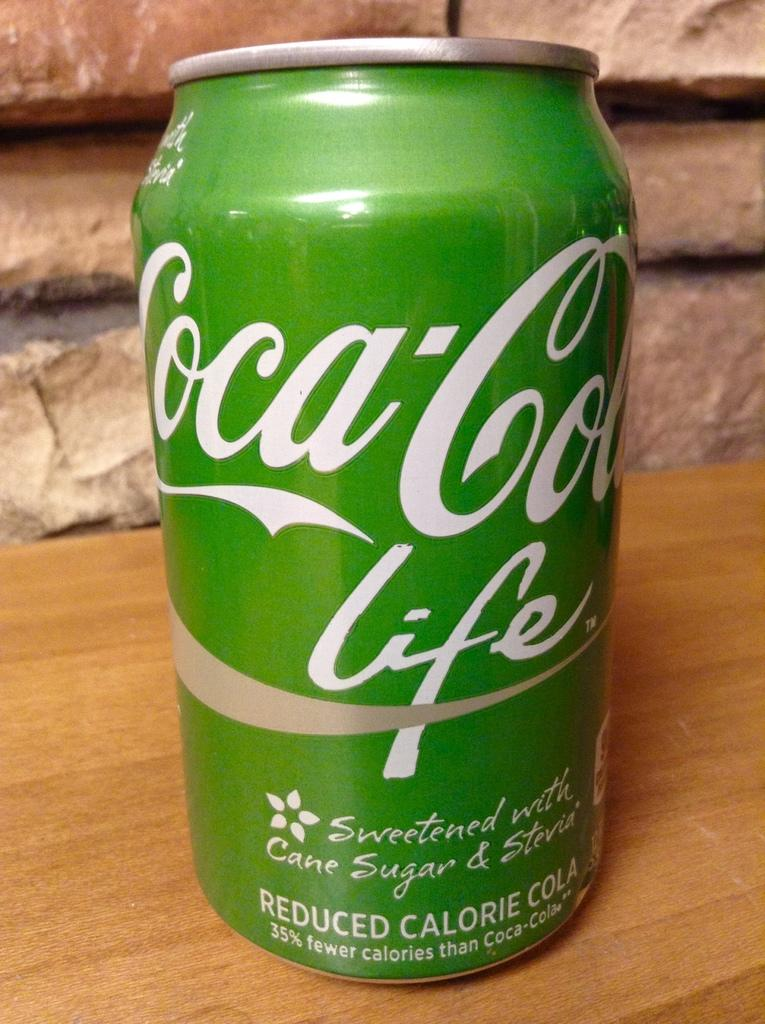<image>
Give a short and clear explanation of the subsequent image. A close up of a green Coca Cola life can which is sweetened using Cane sugar & Stevia. 